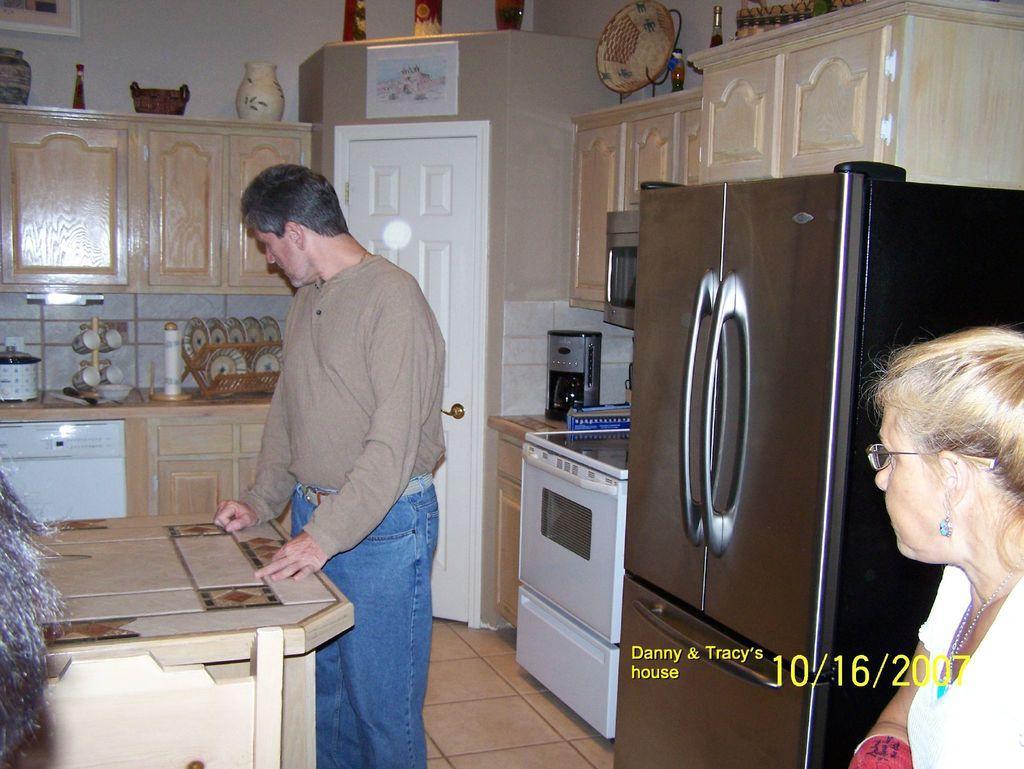Can you describe this image briefly? This is the man standing. This looks like a table. These are the cupboards with the wooden doors. I can see a gas cooker and coffee machine. This looks like a micro oven. Here is a refrigerator. These are the plates and cups. I can see flower vases, basket and few other things placed above the cupboards. Here is the woman. This is the watermark on the image. 